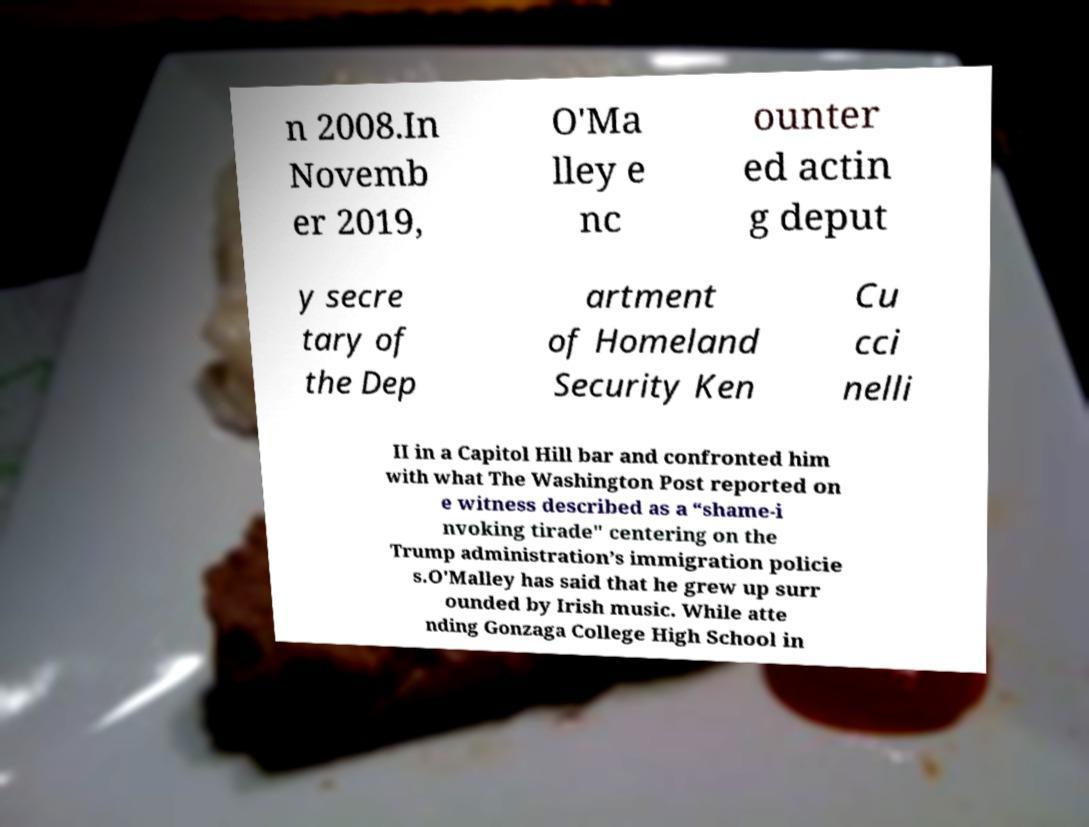For documentation purposes, I need the text within this image transcribed. Could you provide that? n 2008.In Novemb er 2019, O'Ma lley e nc ounter ed actin g deput y secre tary of the Dep artment of Homeland Security Ken Cu cci nelli II in a Capitol Hill bar and confronted him with what The Washington Post reported on e witness described as a “shame-i nvoking tirade" centering on the Trump administration’s immigration policie s.O'Malley has said that he grew up surr ounded by Irish music. While atte nding Gonzaga College High School in 